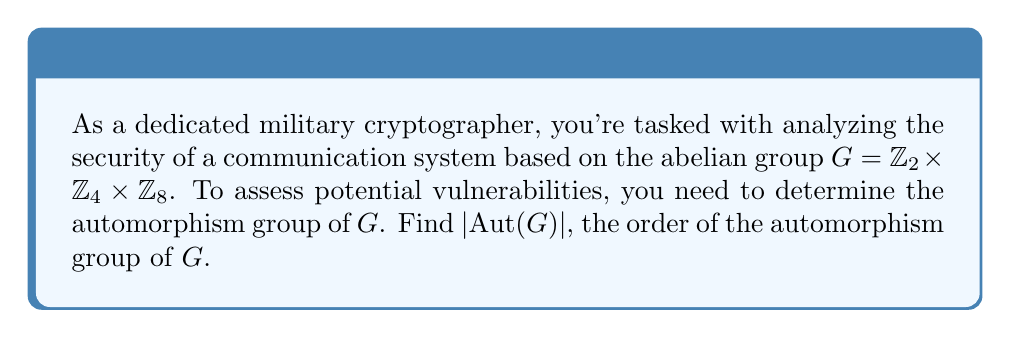Show me your answer to this math problem. Let's approach this step-by-step:

1) First, recall the structure theorem for automorphisms of finite abelian groups:
   For $G = \mathbb{Z}_{p_1^{a_1}} \times \mathbb{Z}_{p_2^{a_2}} \times \cdots \times \mathbb{Z}_{p_k^{a_k}}$ where $p_1 \leq p_2 \leq \cdots \leq p_k$ are primes,
   $$|\text{Aut}(G)| = |\text{GL}(n_1, p_1)| \cdot |\text{GL}(n_2, p_2)| \cdots |\text{GL}(n_k, p_k)| \cdot p_1^{n_1n_2} \cdot p_1^{n_1n_3} \cdots p_{k-1}^{n_{k-1}n_k}$$
   where $n_i$ is the number of factors with the same $p_i$.

2) In our case, $G = \mathbb{Z}_2 \times \mathbb{Z}_4 \times \mathbb{Z}_8 = \mathbb{Z}_{2^1} \times \mathbb{Z}_{2^2} \times \mathbb{Z}_{2^3}$

3) We have only one prime $p_1 = 2$, and $n_1 = 1, n_2 = 1, n_3 = 1$

4) $|\text{GL}(1, 2)| = 1$ for all three factors

5) The additional factor is $2^{1\cdot1 + 1\cdot1 + 1\cdot1} = 2^3 = 8$

6) Therefore, $|\text{Aut}(G)| = 1 \cdot 1 \cdot 1 \cdot 8 = 8$
Answer: $|\text{Aut}(G)| = 8$ 